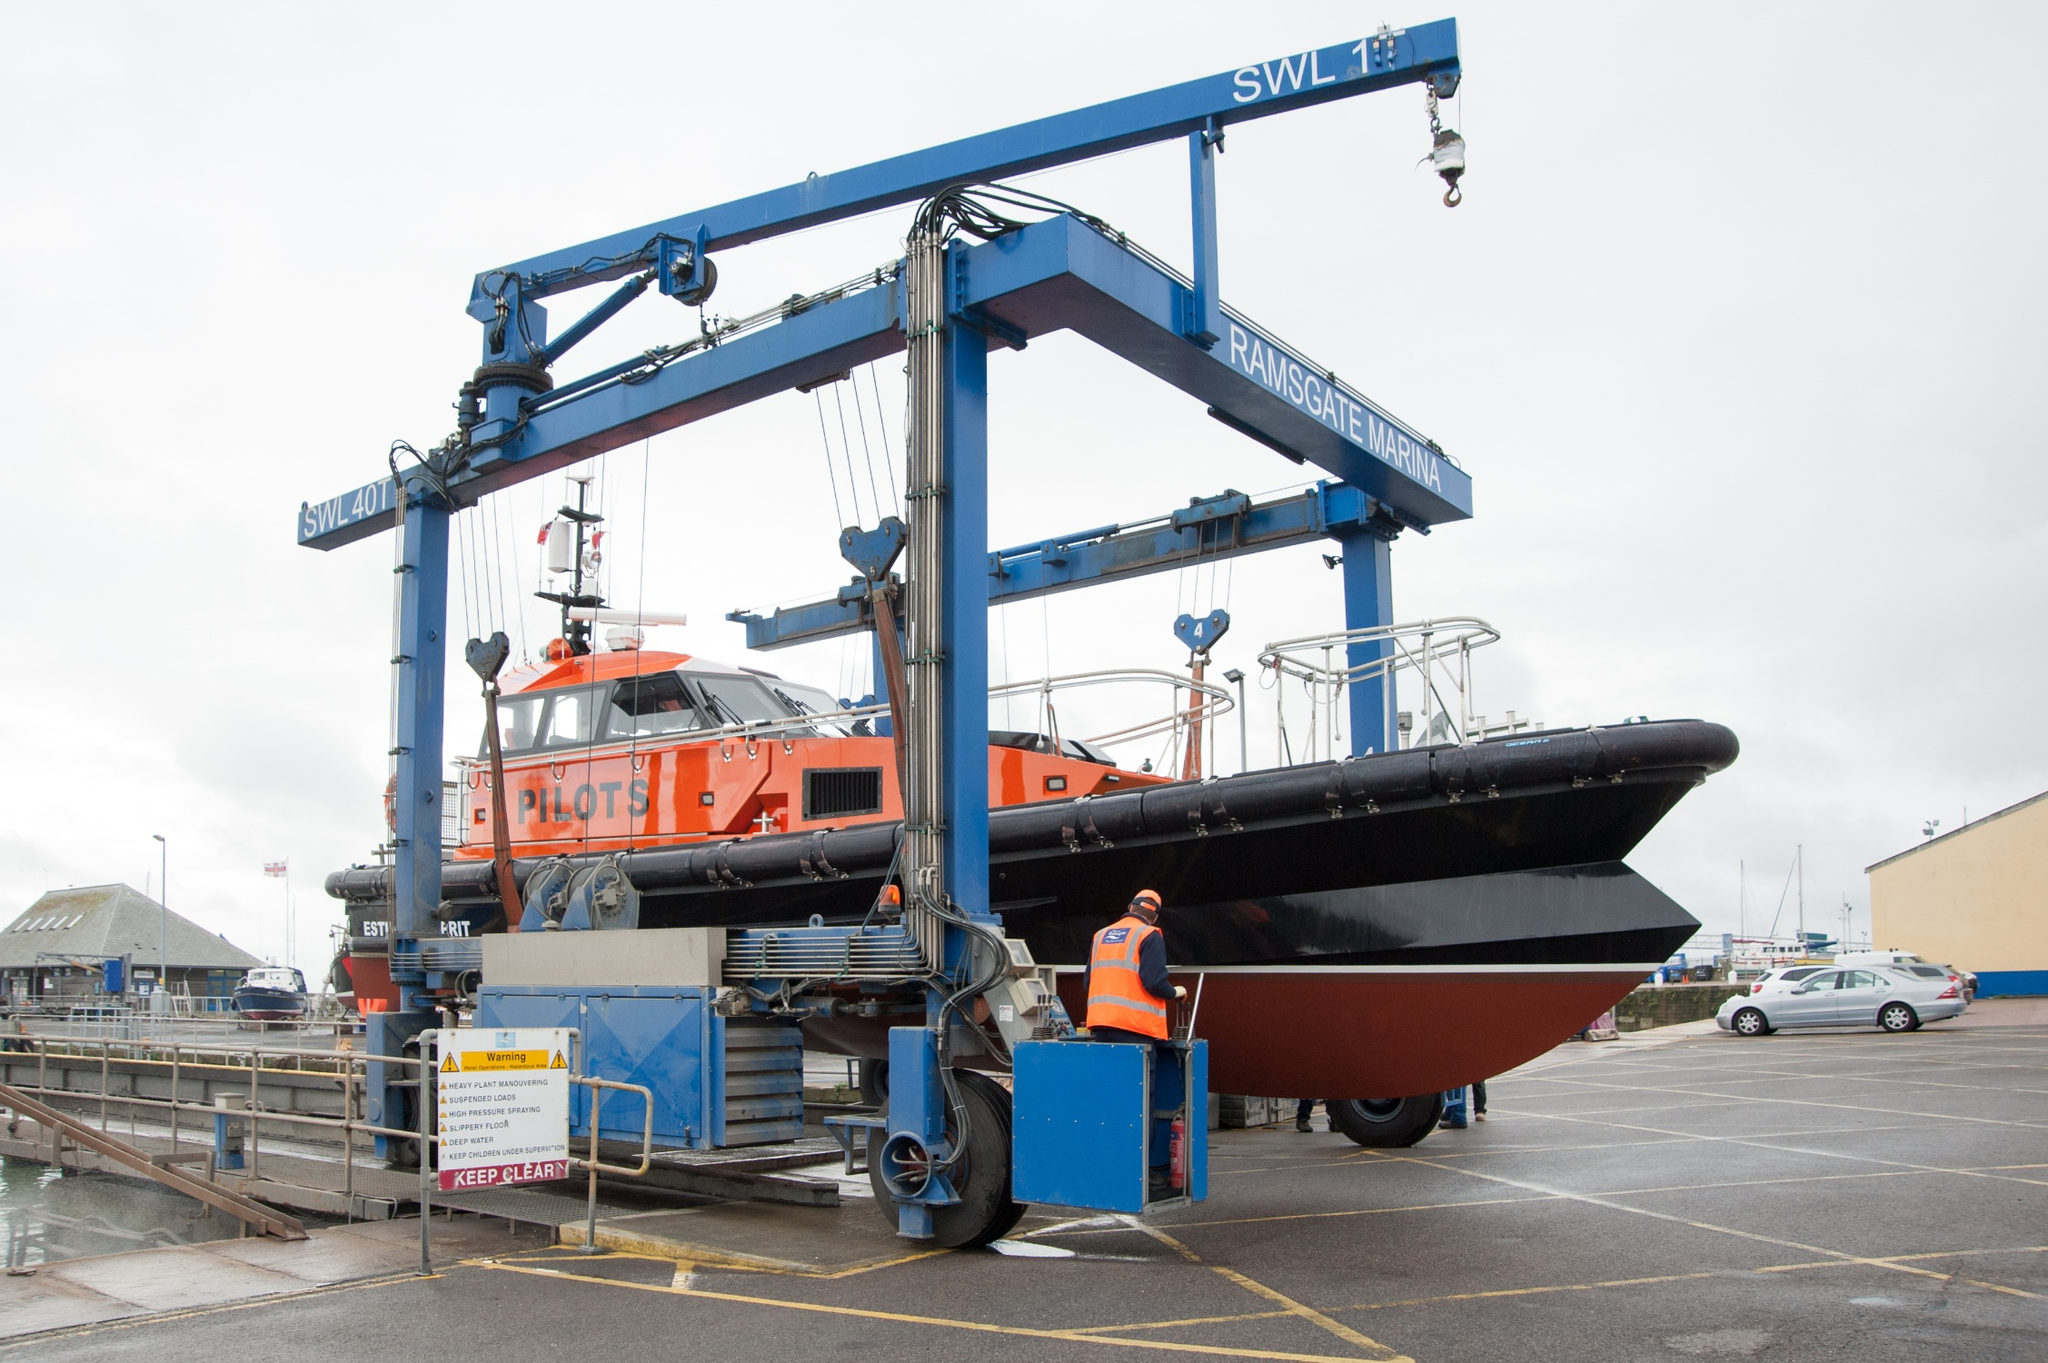What does 'SWL 7t' stand for and why is it significant? 'SWL 7t' stands for 'Safe Working Load of 7 tonnes'. This designation is critical as it informs operators and engineers of the maximum safe weight the crane can lift. Ensuring that the crane operates within this limit is crucial for safety and efficiency, preventing overloading and potential mechanical failure. 